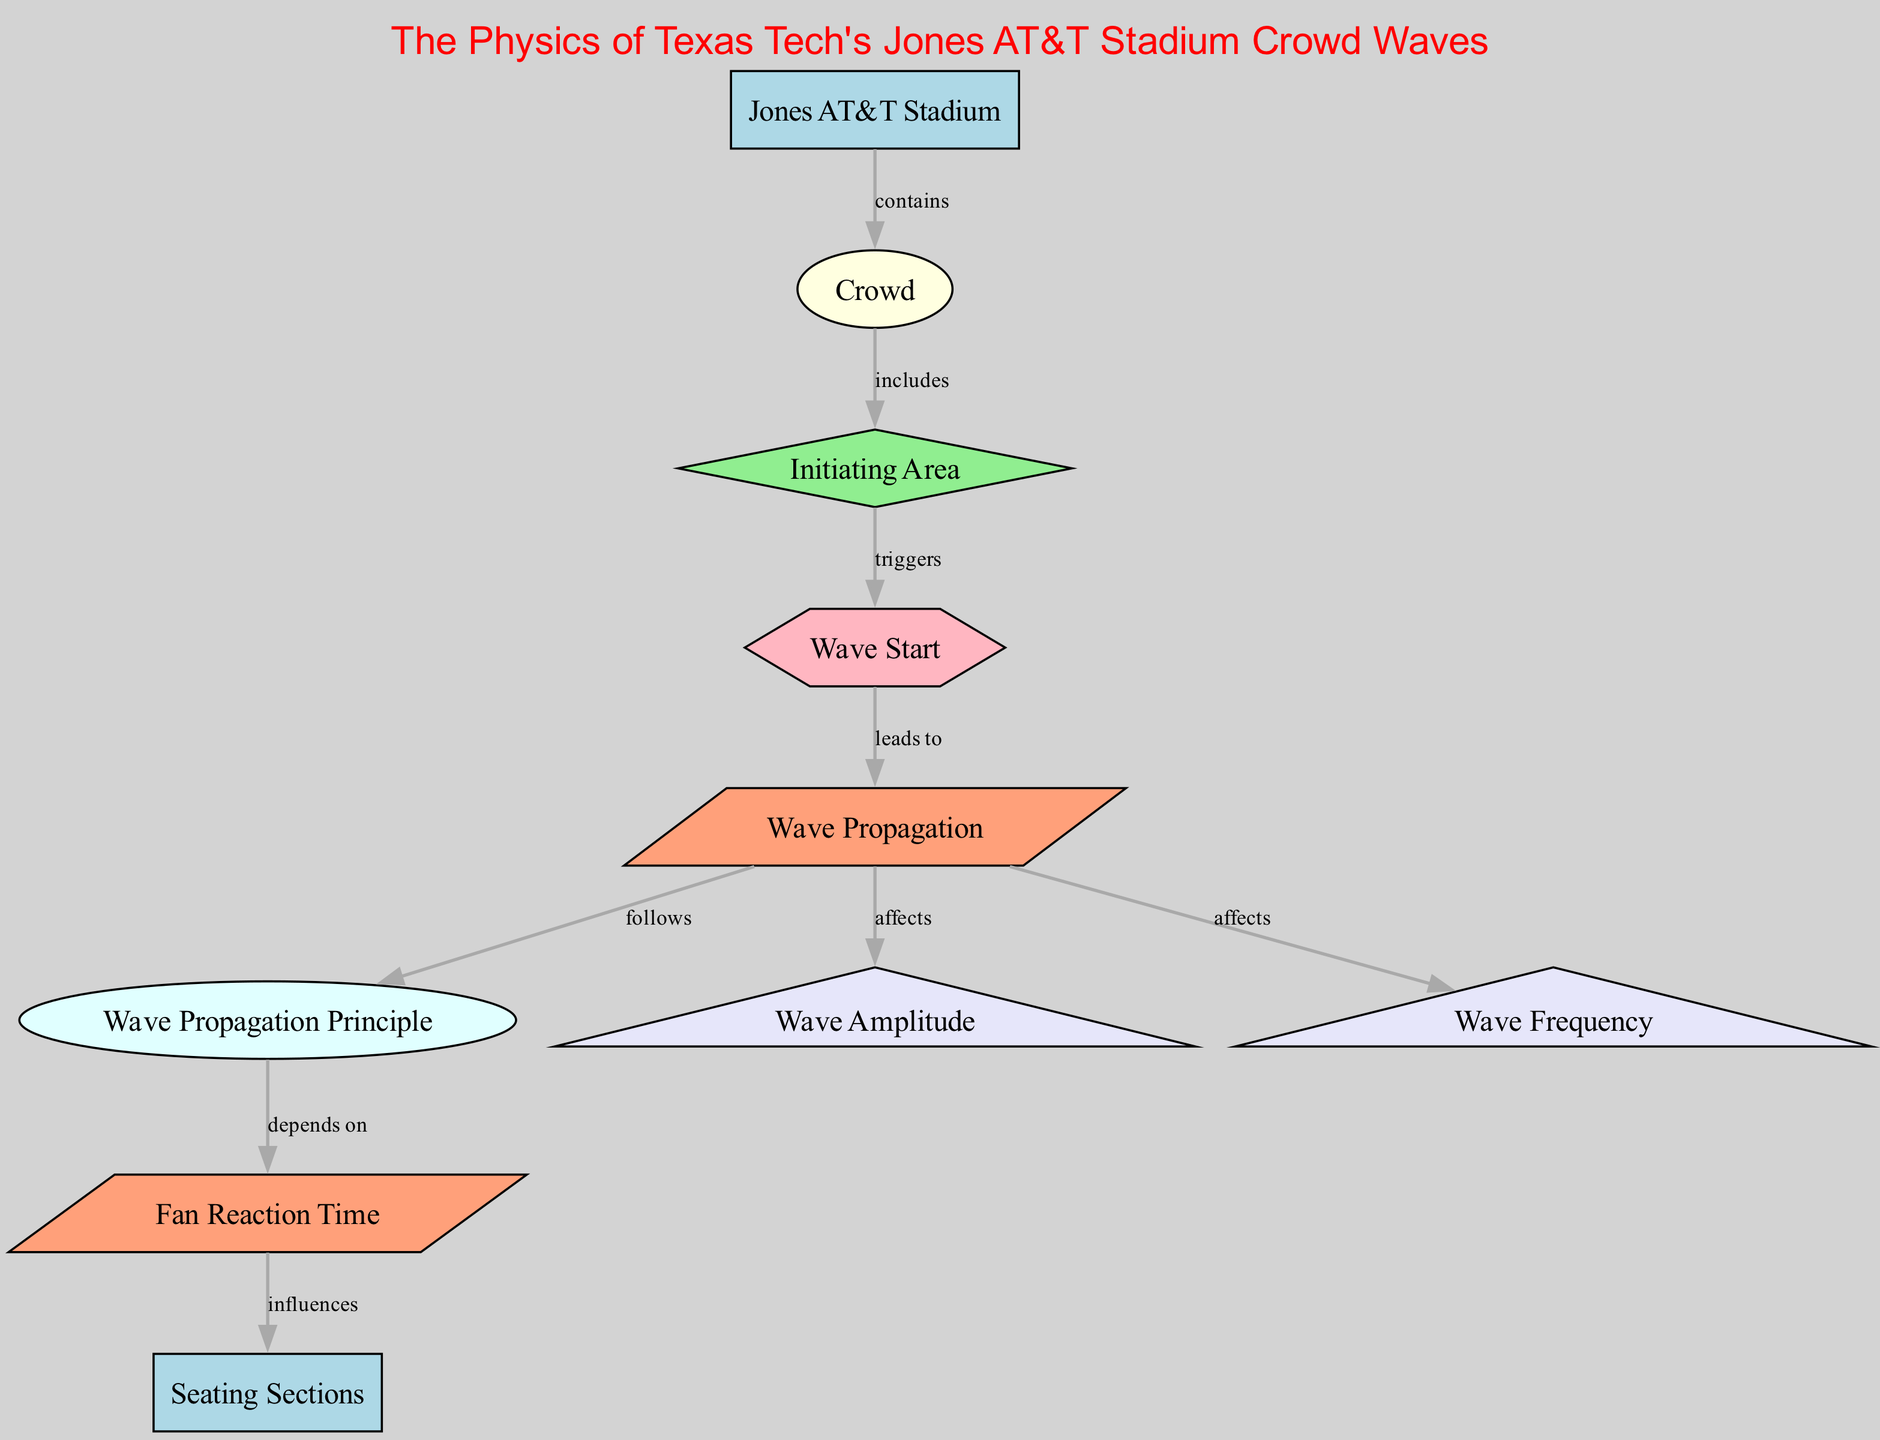What is the main location depicted in the diagram? The main location depicted in the diagram is identified by the node labeled "Jones AT&T Stadium," which is shown at the first level in the nodes.
Answer: Jones AT&T Stadium Which node represents the initiating area for the wave? The node representing the initiating area in the diagram is labeled "Initiating Area." It is explicitly mentioned that this area is where the wave can start.
Answer: Initiating Area How does the wave start according to the diagram? According to the diagram, the wave starts when fans in the initiating area trigger the event labeled "Wave Start," demonstrating the cause-and-effect relationship.
Answer: Wave Start What type of measurement is related to the amplitude of the wave? The type of measurement related to the amplitude of the wave is identified by the node labeled "Wave Amplitude." This indicates that amplitude is measured in relation to wave propagation.
Answer: Wave Amplitude Which process influences the wave's propagation? The wave's propagation is influenced by the process labeled "Fan Reaction Time," indicating that how quickly fans react affects how the wave travels through the crowd.
Answer: Fan Reaction Time How many nodes are involved in the crowd wave process? By counting the distinct nodes present, which include the main elements related to the crowd wave process, we find there are a total of ten nodes in the diagram.
Answer: Ten What happens after the wave starts? After the wave starts, the process that follows is the "Wave Propagation," indicating that the wave travels through the crowd once initiated by the fans.
Answer: Wave Propagation Which node follows the "Wave Propagation" in the diagram? The node that follows the "Wave Propagation" is the one labeled "Wave Propagation Principle," showing the relationship where propagation adheres to physical laws.
Answer: Wave Propagation Principle What influences the wave propagation in different sections? The wave propagation in different sections is influenced by "Fan Reaction Time," showing that reactions vary across different seating areas, impacting the overall wave movement.
Answer: Fan Reaction Time 